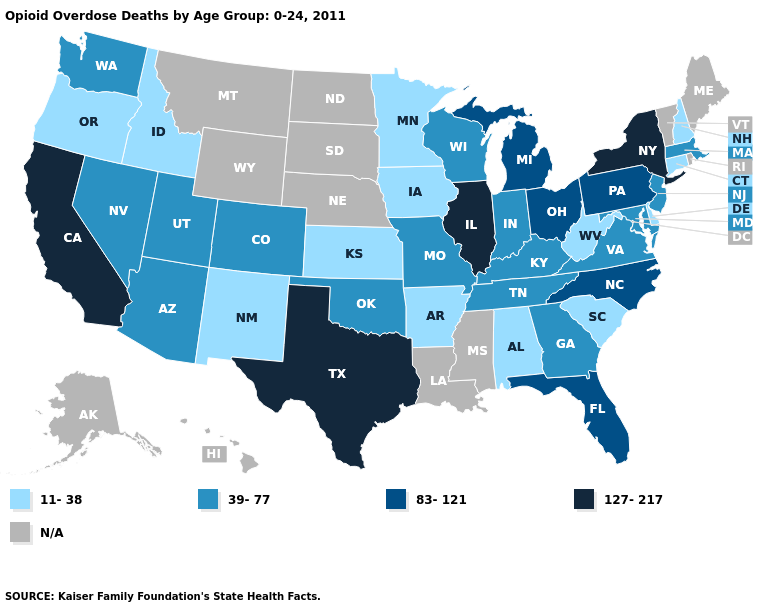What is the value of Tennessee?
Give a very brief answer. 39-77. Name the states that have a value in the range 83-121?
Write a very short answer. Florida, Michigan, North Carolina, Ohio, Pennsylvania. Does Arkansas have the lowest value in the USA?
Short answer required. Yes. What is the value of Montana?
Give a very brief answer. N/A. What is the highest value in the USA?
Keep it brief. 127-217. Which states have the lowest value in the MidWest?
Quick response, please. Iowa, Kansas, Minnesota. What is the highest value in states that border Wyoming?
Answer briefly. 39-77. What is the lowest value in states that border California?
Answer briefly. 11-38. Does New York have the highest value in the USA?
Answer briefly. Yes. What is the value of Arizona?
Answer briefly. 39-77. What is the highest value in the USA?
Keep it brief. 127-217. Does Colorado have the lowest value in the West?
Keep it brief. No. How many symbols are there in the legend?
Be succinct. 5. Name the states that have a value in the range 127-217?
Short answer required. California, Illinois, New York, Texas. Which states hav the highest value in the South?
Keep it brief. Texas. 